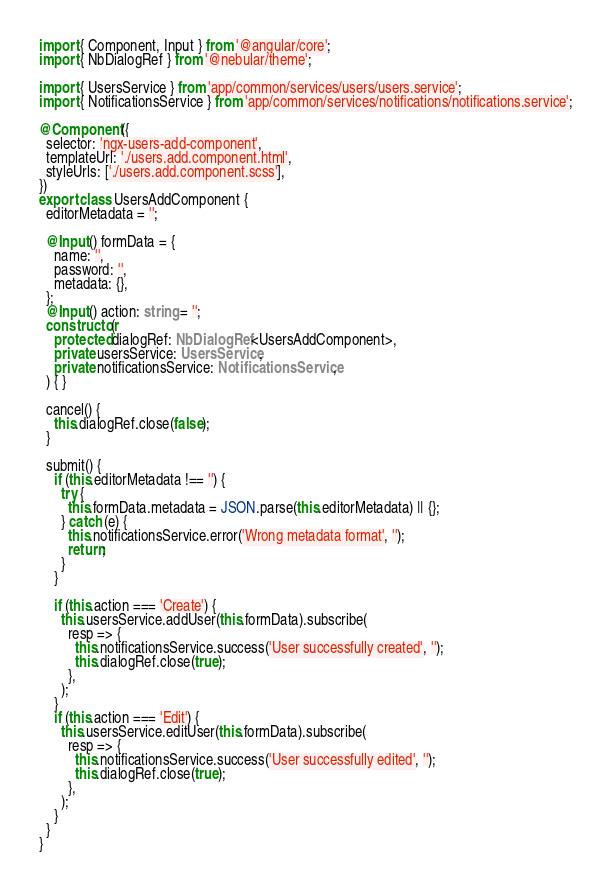<code> <loc_0><loc_0><loc_500><loc_500><_TypeScript_>import { Component, Input } from '@angular/core';
import { NbDialogRef } from '@nebular/theme';

import { UsersService } from 'app/common/services/users/users.service';
import { NotificationsService } from 'app/common/services/notifications/notifications.service';

@Component({
  selector: 'ngx-users-add-component',
  templateUrl: './users.add.component.html',
  styleUrls: ['./users.add.component.scss'],
})
export class UsersAddComponent {
  editorMetadata = '';

  @Input() formData = {
    name: '',
    password: '',
    metadata: {},
  };
  @Input() action: string = '';
  constructor(
    protected dialogRef: NbDialogRef<UsersAddComponent>,
    private usersService: UsersService,
    private notificationsService: NotificationsService,
  ) { }

  cancel() {
    this.dialogRef.close(false);
  }

  submit() {
    if (this.editorMetadata !== '') {
      try {
        this.formData.metadata = JSON.parse(this.editorMetadata) || {};
      } catch (e) {
        this.notificationsService.error('Wrong metadata format', '');
        return;
      }
    }

    if (this.action === 'Create') {
      this.usersService.addUser(this.formData).subscribe(
        resp => {
          this.notificationsService.success('User successfully created', '');
          this.dialogRef.close(true);
        },
      );
    }
    if (this.action === 'Edit') {
      this.usersService.editUser(this.formData).subscribe(
        resp => {
          this.notificationsService.success('User successfully edited', '');
          this.dialogRef.close(true);
        },
      );
    }
  }
}
</code> 